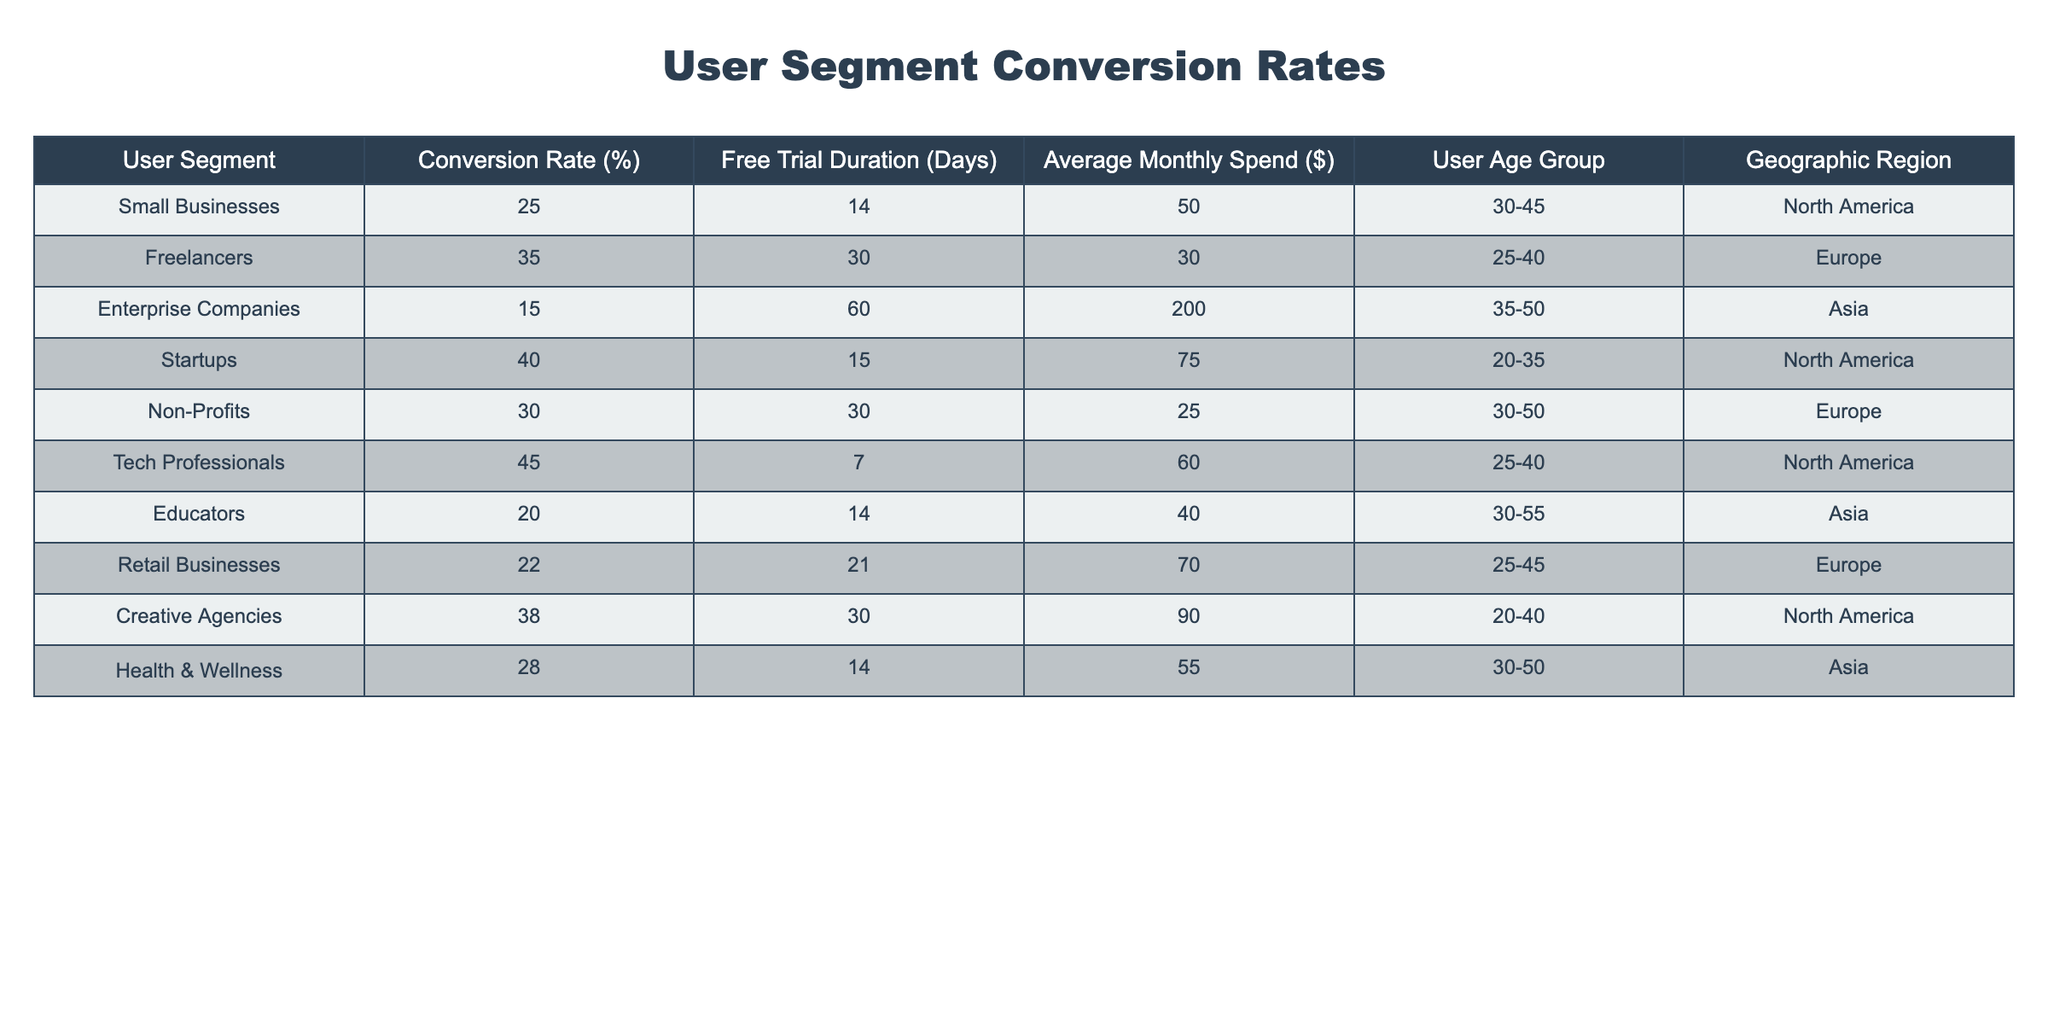What is the conversion rate for Freelancers? The table provides a specific rate for each user segment. By locating the row for Freelancers, I can see their conversion rate is listed as 35%.
Answer: 35% Which user segment has the highest conversion rate? By reviewing all the conversion rates in the table, Tech Professionals have the highest rate at 45%, compared to other segments.
Answer: 45% What is the average free trial duration for all user segments? To calculate the average, I sum the free trial durations of all segments: (14 + 30 + 60 + 15 + 30 + 7 + 14 + 21 + 30 + 14) =  7.4, and then divide by the number of segments, which is 10:  14.4/10 = 24.4 days.
Answer: 24.4 days Are Startups' average monthly spend and conversion rate higher than that of Non-Profits? Startups have an average monthly spend of 75 and a conversion rate of 40%, while Non-Profits have a spend of 25 and a conversion rate of 30%. Thus, both metrics for Startups are higher than those for Non-Profits.
Answer: Yes Which geographic region has the lowest conversion rate among all user segments? Examining the conversion rates by geographic region, Enterprise Companies in Asia have the lowest conversion rate at 15%.
Answer: 15% 